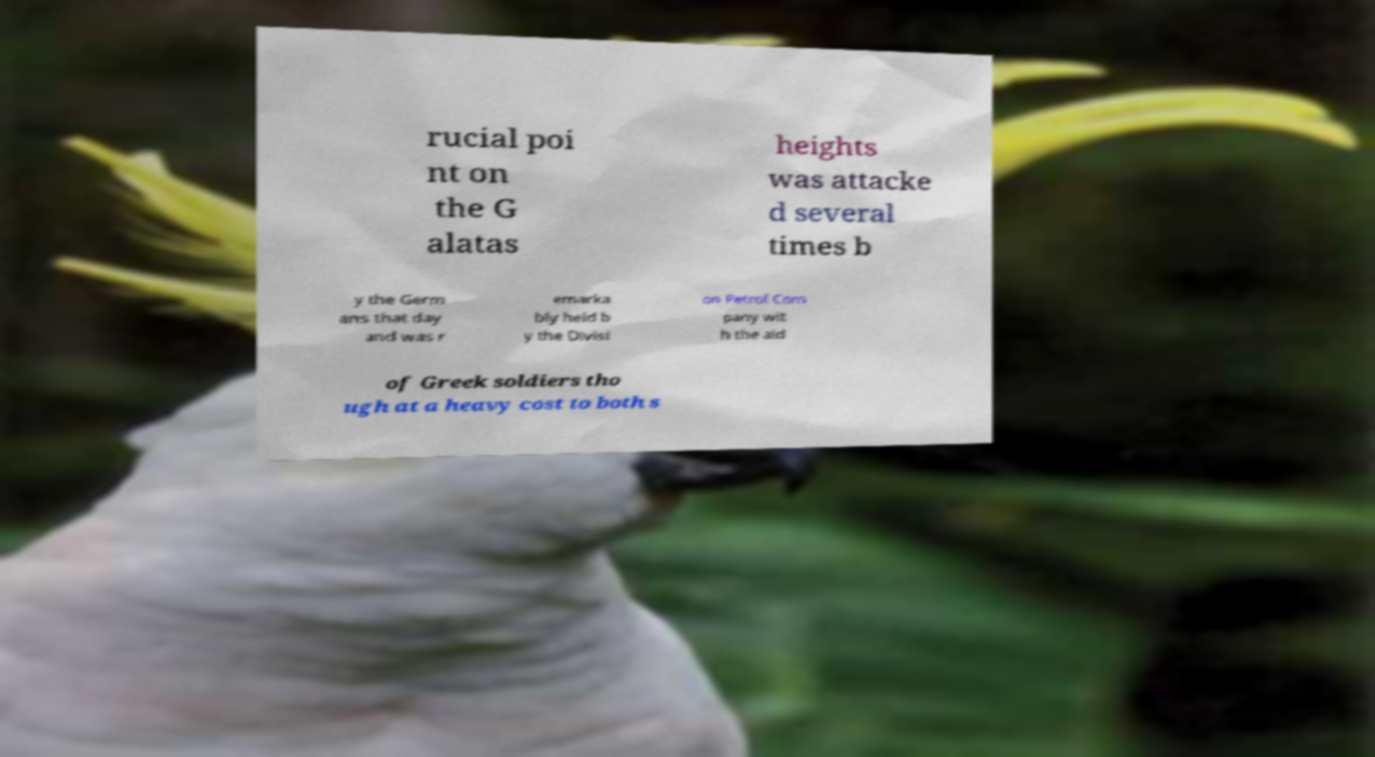Please read and relay the text visible in this image. What does it say? rucial poi nt on the G alatas heights was attacke d several times b y the Germ ans that day and was r emarka bly held b y the Divisi on Petrol Com pany wit h the aid of Greek soldiers tho ugh at a heavy cost to both s 